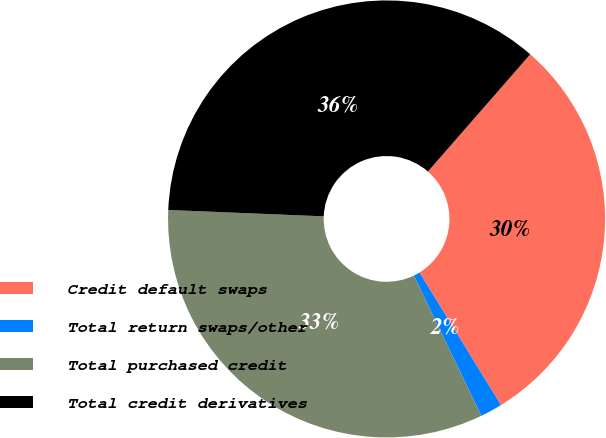Convert chart to OTSL. <chart><loc_0><loc_0><loc_500><loc_500><pie_chart><fcel>Credit default swaps<fcel>Total return swaps/other<fcel>Total purchased credit<fcel>Total credit derivatives<nl><fcel>29.81%<fcel>1.63%<fcel>32.79%<fcel>35.77%<nl></chart> 